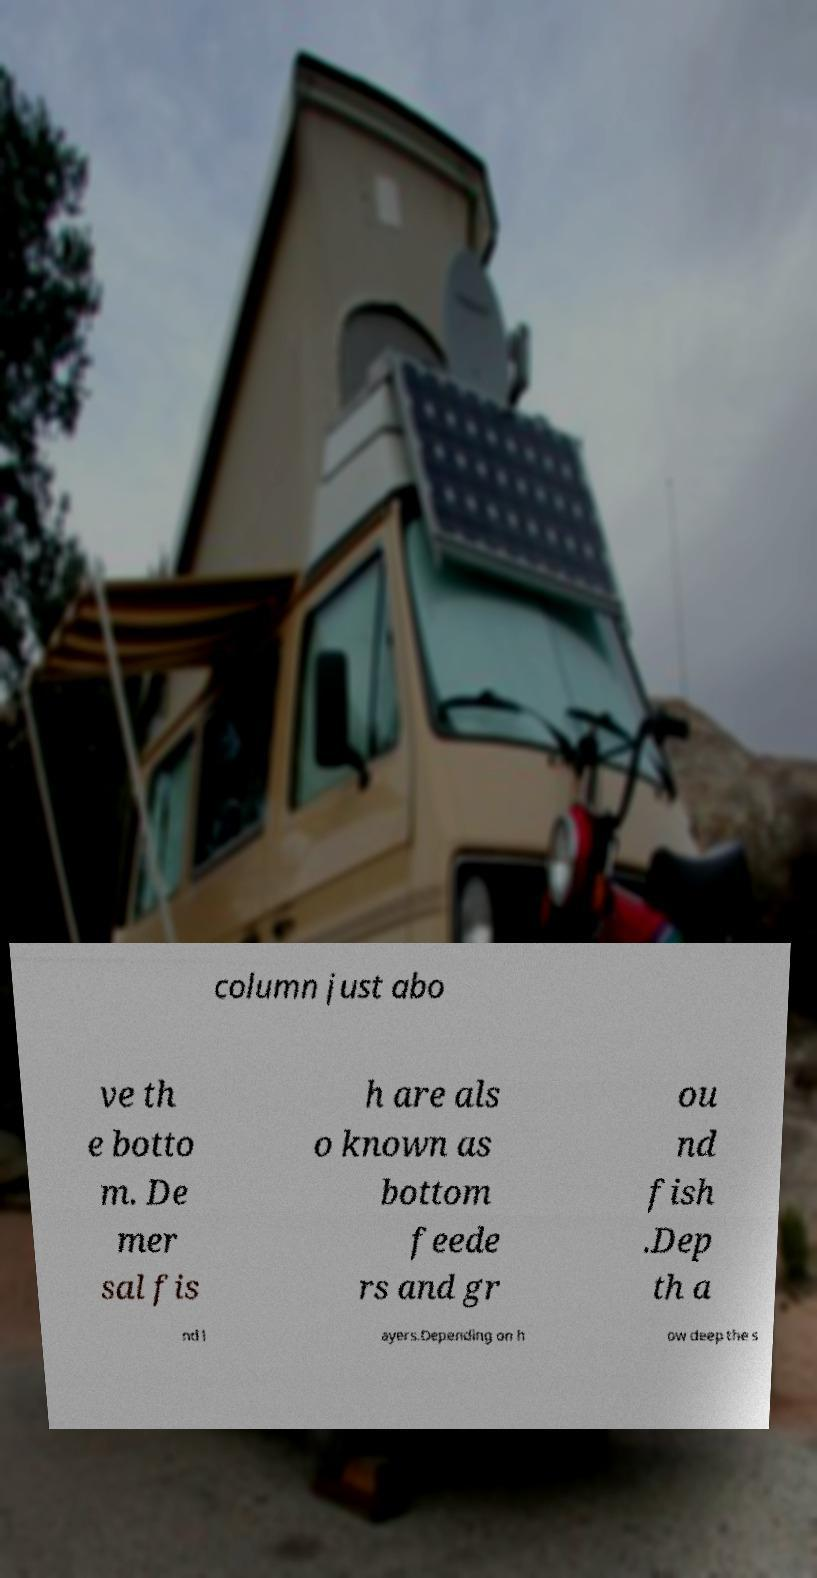I need the written content from this picture converted into text. Can you do that? column just abo ve th e botto m. De mer sal fis h are als o known as bottom feede rs and gr ou nd fish .Dep th a nd l ayers.Depending on h ow deep the s 